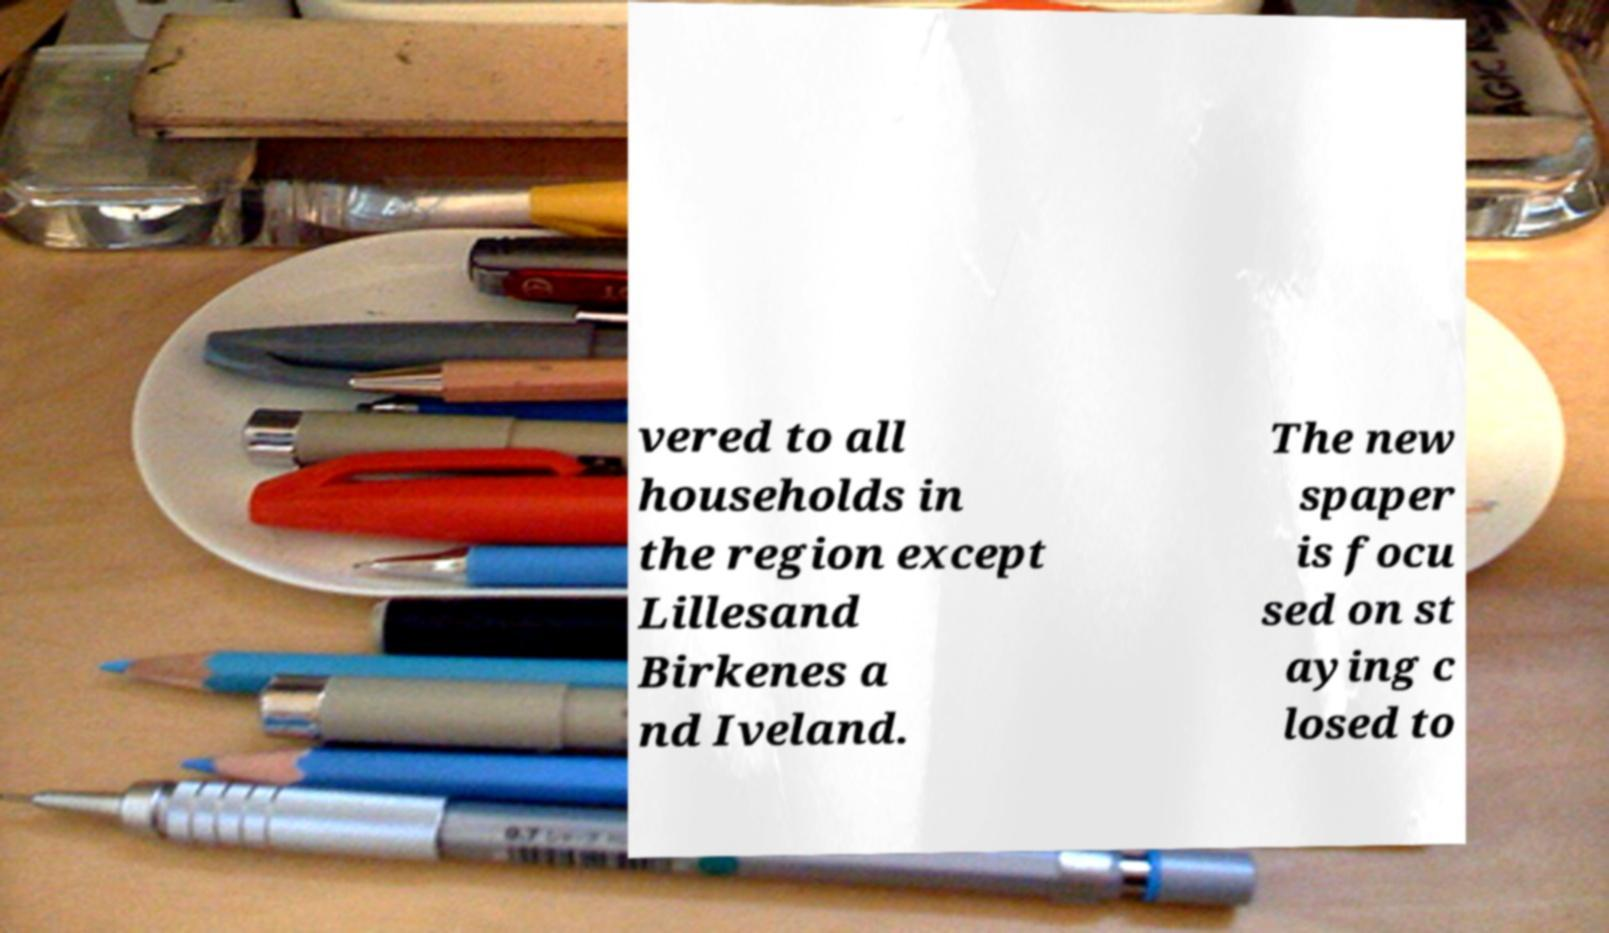There's text embedded in this image that I need extracted. Can you transcribe it verbatim? vered to all households in the region except Lillesand Birkenes a nd Iveland. The new spaper is focu sed on st aying c losed to 